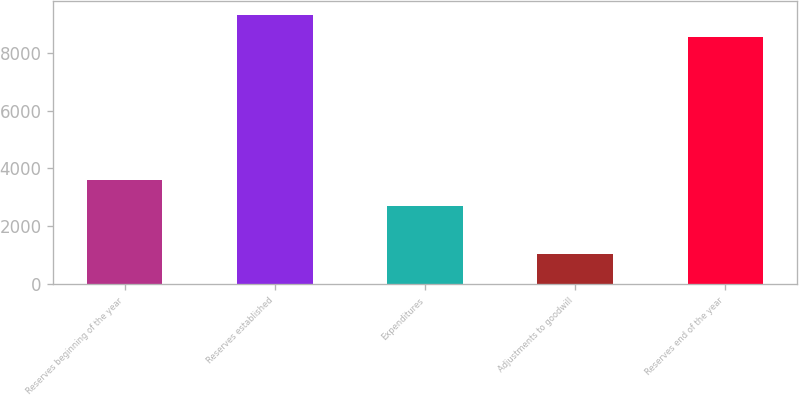<chart> <loc_0><loc_0><loc_500><loc_500><bar_chart><fcel>Reserves beginning of the year<fcel>Reserves established<fcel>Expenditures<fcel>Adjustments to goodwill<fcel>Reserves end of the year<nl><fcel>3602<fcel>9320.1<fcel>2698<fcel>1043<fcel>8555<nl></chart> 